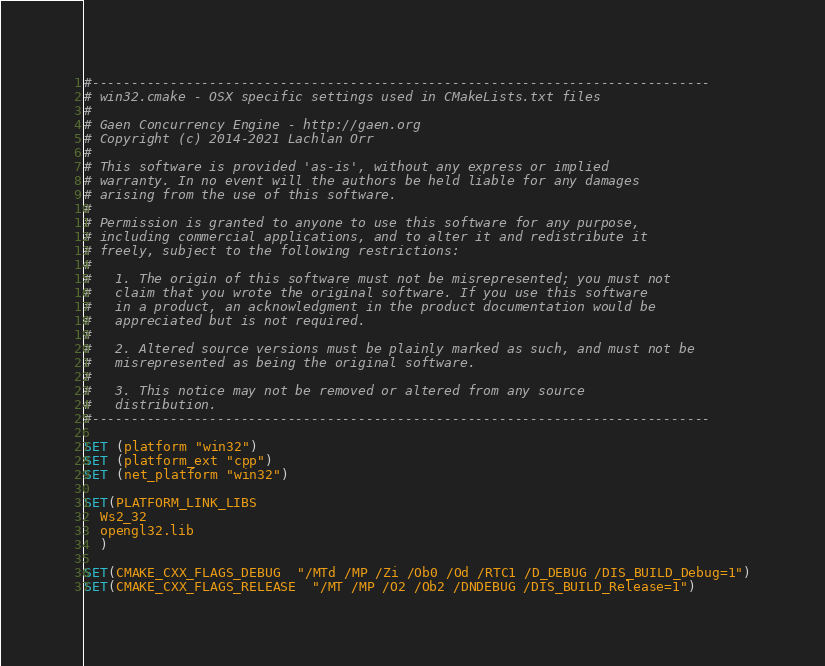<code> <loc_0><loc_0><loc_500><loc_500><_CMake_>#-------------------------------------------------------------------------------
# win32.cmake - OSX specific settings used in CMakeLists.txt files
#
# Gaen Concurrency Engine - http://gaen.org
# Copyright (c) 2014-2021 Lachlan Orr
#
# This software is provided 'as-is', without any express or implied
# warranty. In no event will the authors be held liable for any damages
# arising from the use of this software.
#
# Permission is granted to anyone to use this software for any purpose,
# including commercial applications, and to alter it and redistribute it
# freely, subject to the following restrictions:
#
#   1. The origin of this software must not be misrepresented; you must not
#   claim that you wrote the original software. If you use this software
#   in a product, an acknowledgment in the product documentation would be
#   appreciated but is not required.
#
#   2. Altered source versions must be plainly marked as such, and must not be
#   misrepresented as being the original software.
#
#   3. This notice may not be removed or altered from any source
#   distribution.
#-------------------------------------------------------------------------------

SET (platform "win32")
SET (platform_ext "cpp")
SET (net_platform "win32")

SET(PLATFORM_LINK_LIBS
  Ws2_32
  opengl32.lib
  )

SET(CMAKE_CXX_FLAGS_DEBUG  "/MTd /MP /Zi /Ob0 /Od /RTC1 /D_DEBUG /DIS_BUILD_Debug=1")
SET(CMAKE_CXX_FLAGS_RELEASE  "/MT /MP /O2 /Ob2 /DNDEBUG /DIS_BUILD_Release=1")</code> 